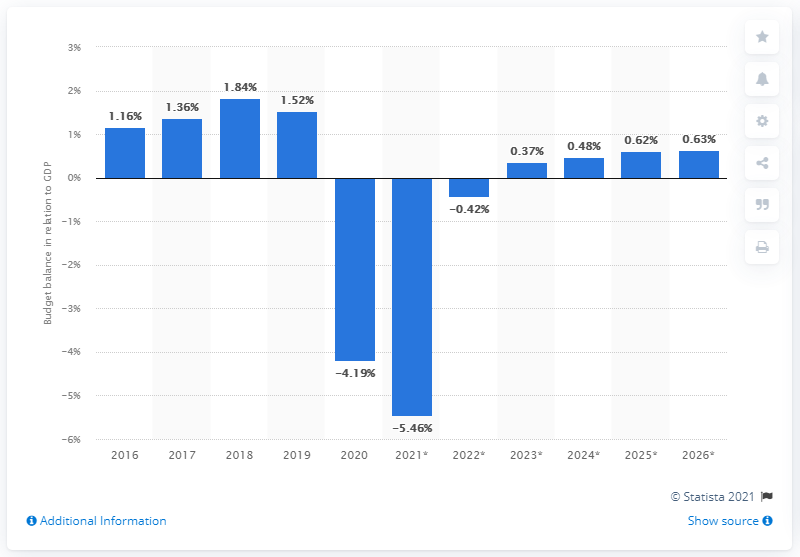Draw attention to some important aspects in this diagram. Germany's budget balance last matched its GDP in 2020. 